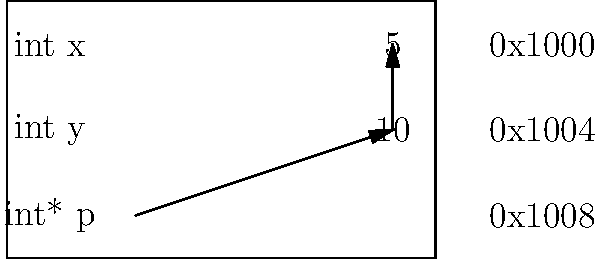Given the memory block diagram above representing a simple data structure, what is the total memory allocation in bytes for this structure? To calculate the total memory allocation, we need to analyze each element in the structure:

1. The structure contains three variables: `int x`, `int y`, and `int* p`.

2. In most modern C/C++ implementations:
   - An `int` typically occupies 4 bytes
   - A pointer (int*) typically occupies 8 bytes on a 64-bit system

3. Let's calculate:
   - `int x`: 4 bytes
   - `int y`: 4 bytes
   - `int* p`: 8 bytes

4. Total memory allocation:
   $4 + 4 + 8 = 16$ bytes

Therefore, the total memory allocation for this structure is 16 bytes.
Answer: 16 bytes 